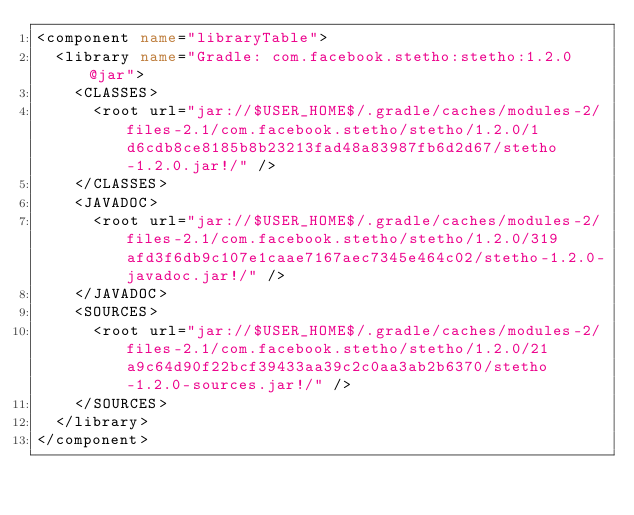Convert code to text. <code><loc_0><loc_0><loc_500><loc_500><_XML_><component name="libraryTable">
  <library name="Gradle: com.facebook.stetho:stetho:1.2.0@jar">
    <CLASSES>
      <root url="jar://$USER_HOME$/.gradle/caches/modules-2/files-2.1/com.facebook.stetho/stetho/1.2.0/1d6cdb8ce8185b8b23213fad48a83987fb6d2d67/stetho-1.2.0.jar!/" />
    </CLASSES>
    <JAVADOC>
      <root url="jar://$USER_HOME$/.gradle/caches/modules-2/files-2.1/com.facebook.stetho/stetho/1.2.0/319afd3f6db9c107e1caae7167aec7345e464c02/stetho-1.2.0-javadoc.jar!/" />
    </JAVADOC>
    <SOURCES>
      <root url="jar://$USER_HOME$/.gradle/caches/modules-2/files-2.1/com.facebook.stetho/stetho/1.2.0/21a9c64d90f22bcf39433aa39c2c0aa3ab2b6370/stetho-1.2.0-sources.jar!/" />
    </SOURCES>
  </library>
</component></code> 